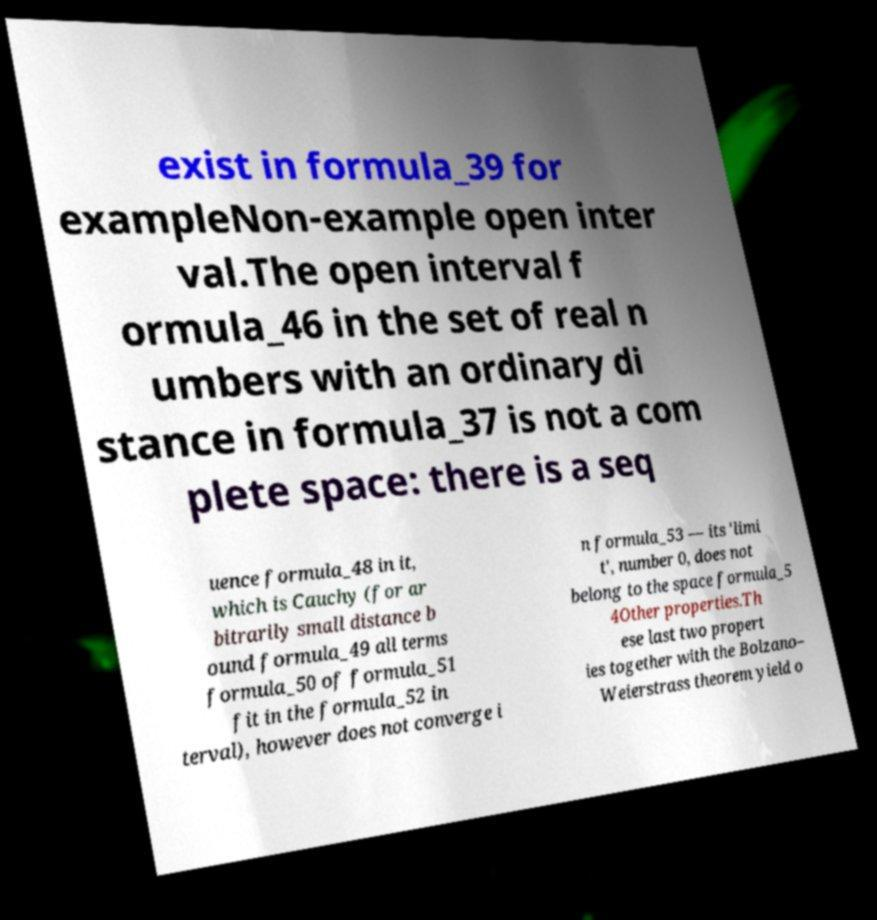Please identify and transcribe the text found in this image. exist in formula_39 for exampleNon-example open inter val.The open interval f ormula_46 in the set of real n umbers with an ordinary di stance in formula_37 is not a com plete space: there is a seq uence formula_48 in it, which is Cauchy (for ar bitrarily small distance b ound formula_49 all terms formula_50 of formula_51 fit in the formula_52 in terval), however does not converge i n formula_53 — its 'limi t', number 0, does not belong to the space formula_5 4Other properties.Th ese last two propert ies together with the Bolzano– Weierstrass theorem yield o 